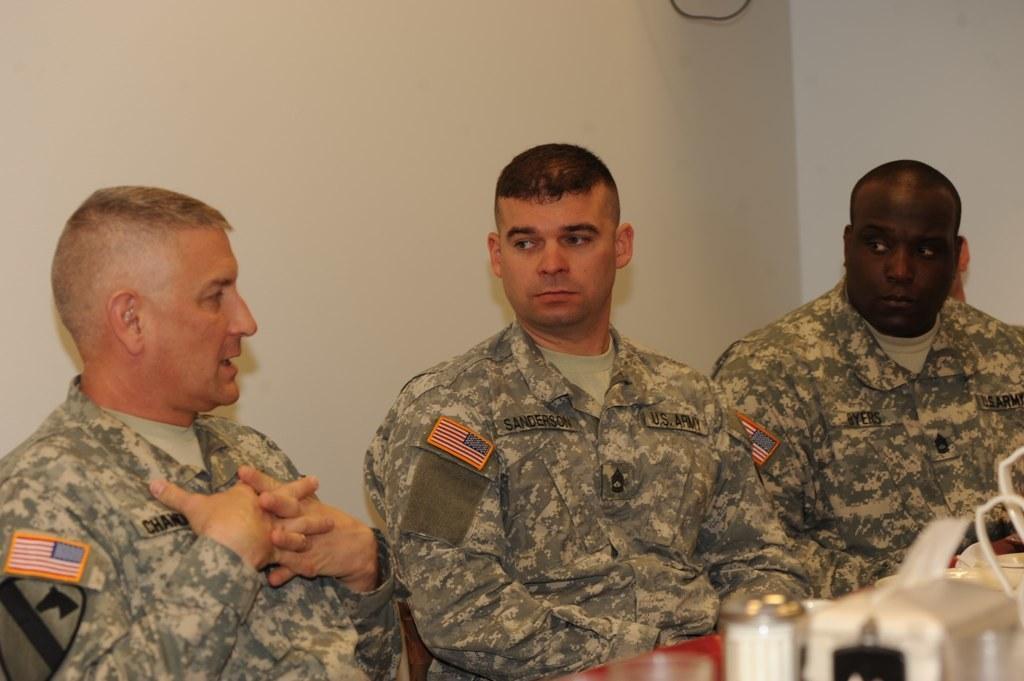Could you give a brief overview of what you see in this image? In this image I can see three men are wearing uniform and setting in front of the table. The man who is on the left side is speaking. The other two men are looking at this man. On the table, I can see few objects. At the back of these people I can see the wall. 